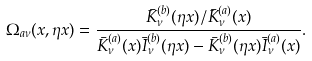<formula> <loc_0><loc_0><loc_500><loc_500>\Omega _ { a \nu } ( x , \eta x ) = \frac { \bar { K } _ { \nu } ^ { ( b ) } ( \eta x ) / \bar { K } _ { \nu } ^ { ( a ) } ( x ) } { \bar { K } _ { \nu } ^ { ( a ) } ( x ) \bar { I } _ { \nu } ^ { ( b ) } ( \eta x ) - \bar { K } _ { \nu } ^ { ( b ) } ( \eta x ) \bar { I } _ { \nu } ^ { ( a ) } ( x ) } .</formula> 